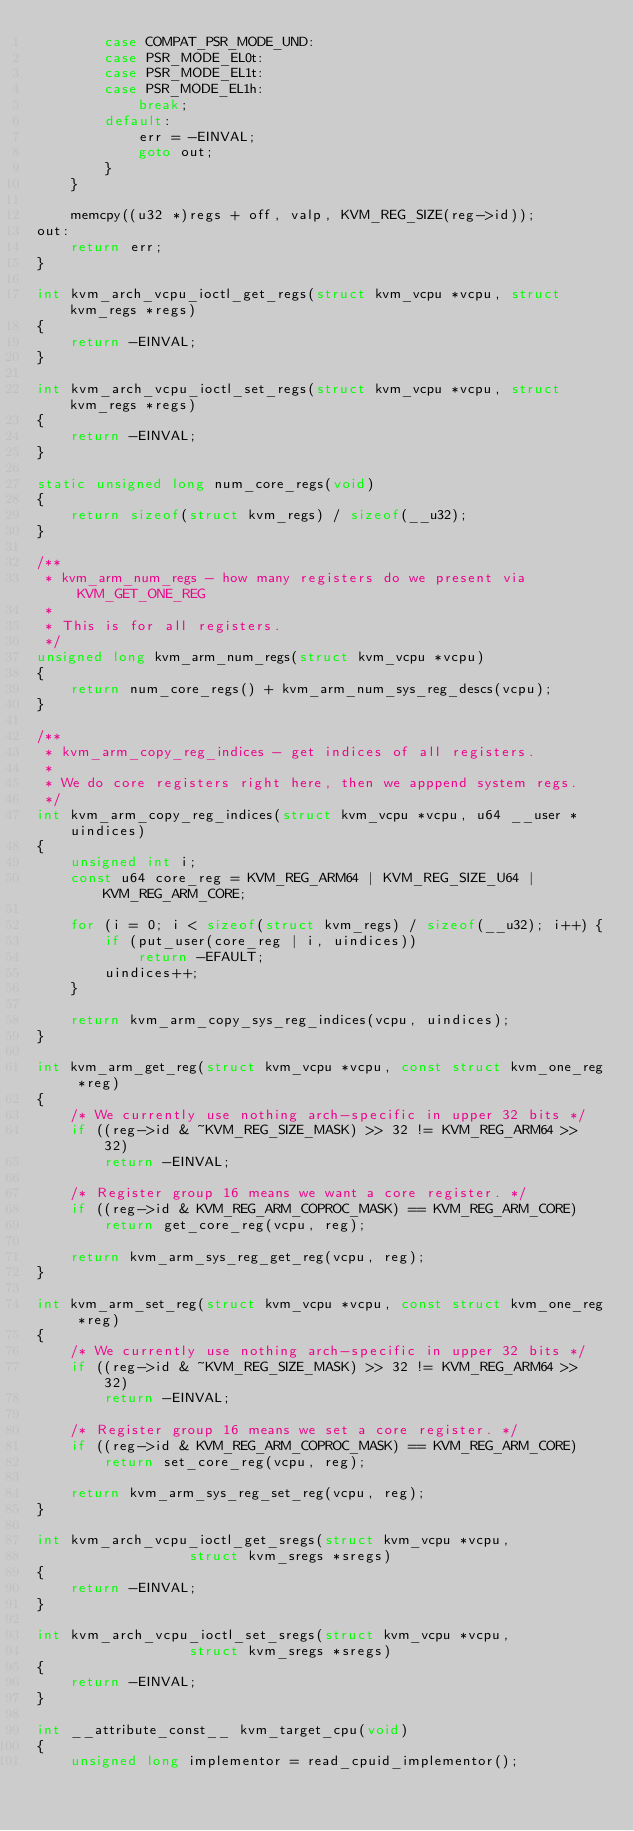Convert code to text. <code><loc_0><loc_0><loc_500><loc_500><_C_>		case COMPAT_PSR_MODE_UND:
		case PSR_MODE_EL0t:
		case PSR_MODE_EL1t:
		case PSR_MODE_EL1h:
			break;
		default:
			err = -EINVAL;
			goto out;
		}
	}

	memcpy((u32 *)regs + off, valp, KVM_REG_SIZE(reg->id));
out:
	return err;
}

int kvm_arch_vcpu_ioctl_get_regs(struct kvm_vcpu *vcpu, struct kvm_regs *regs)
{
	return -EINVAL;
}

int kvm_arch_vcpu_ioctl_set_regs(struct kvm_vcpu *vcpu, struct kvm_regs *regs)
{
	return -EINVAL;
}

static unsigned long num_core_regs(void)
{
	return sizeof(struct kvm_regs) / sizeof(__u32);
}

/**
 * kvm_arm_num_regs - how many registers do we present via KVM_GET_ONE_REG
 *
 * This is for all registers.
 */
unsigned long kvm_arm_num_regs(struct kvm_vcpu *vcpu)
{
	return num_core_regs() + kvm_arm_num_sys_reg_descs(vcpu);
}

/**
 * kvm_arm_copy_reg_indices - get indices of all registers.
 *
 * We do core registers right here, then we apppend system regs.
 */
int kvm_arm_copy_reg_indices(struct kvm_vcpu *vcpu, u64 __user *uindices)
{
	unsigned int i;
	const u64 core_reg = KVM_REG_ARM64 | KVM_REG_SIZE_U64 | KVM_REG_ARM_CORE;

	for (i = 0; i < sizeof(struct kvm_regs) / sizeof(__u32); i++) {
		if (put_user(core_reg | i, uindices))
			return -EFAULT;
		uindices++;
	}

	return kvm_arm_copy_sys_reg_indices(vcpu, uindices);
}

int kvm_arm_get_reg(struct kvm_vcpu *vcpu, const struct kvm_one_reg *reg)
{
	/* We currently use nothing arch-specific in upper 32 bits */
	if ((reg->id & ~KVM_REG_SIZE_MASK) >> 32 != KVM_REG_ARM64 >> 32)
		return -EINVAL;

	/* Register group 16 means we want a core register. */
	if ((reg->id & KVM_REG_ARM_COPROC_MASK) == KVM_REG_ARM_CORE)
		return get_core_reg(vcpu, reg);

	return kvm_arm_sys_reg_get_reg(vcpu, reg);
}

int kvm_arm_set_reg(struct kvm_vcpu *vcpu, const struct kvm_one_reg *reg)
{
	/* We currently use nothing arch-specific in upper 32 bits */
	if ((reg->id & ~KVM_REG_SIZE_MASK) >> 32 != KVM_REG_ARM64 >> 32)
		return -EINVAL;

	/* Register group 16 means we set a core register. */
	if ((reg->id & KVM_REG_ARM_COPROC_MASK) == KVM_REG_ARM_CORE)
		return set_core_reg(vcpu, reg);

	return kvm_arm_sys_reg_set_reg(vcpu, reg);
}

int kvm_arch_vcpu_ioctl_get_sregs(struct kvm_vcpu *vcpu,
				  struct kvm_sregs *sregs)
{
	return -EINVAL;
}

int kvm_arch_vcpu_ioctl_set_sregs(struct kvm_vcpu *vcpu,
				  struct kvm_sregs *sregs)
{
	return -EINVAL;
}

int __attribute_const__ kvm_target_cpu(void)
{
	unsigned long implementor = read_cpuid_implementor();</code> 